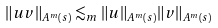Convert formula to latex. <formula><loc_0><loc_0><loc_500><loc_500>\| u v \| _ { A ^ { m } ( s ) } \lesssim _ { m } \| u \| _ { A ^ { m } ( s ) } \| v \| _ { A ^ { m } ( s ) }</formula> 